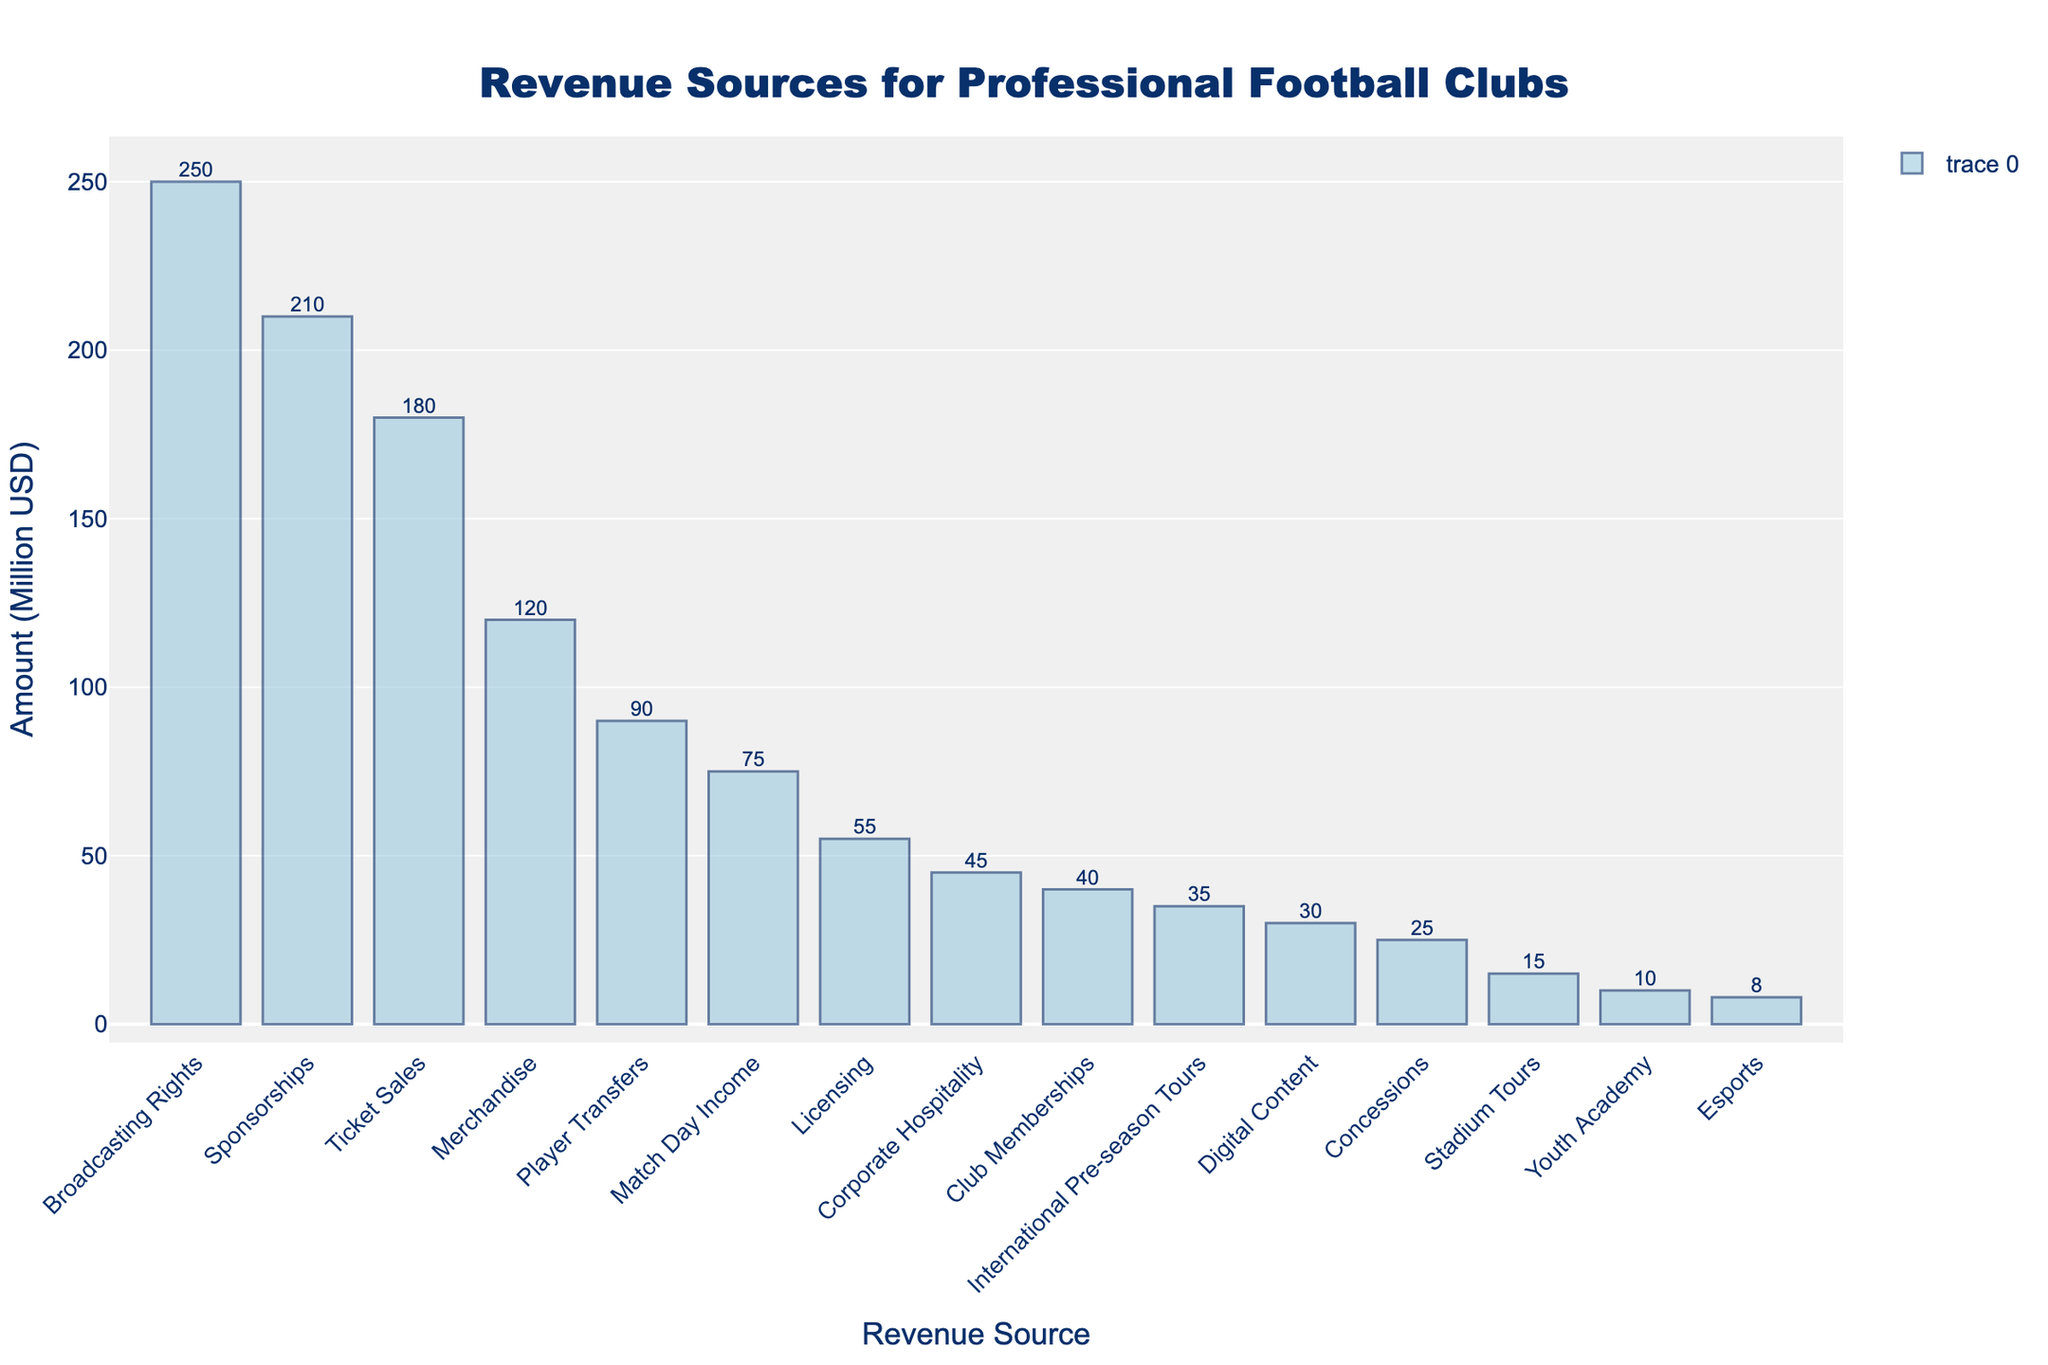which revenue source generated the highest amount? To determine the highest amount generated by a revenue source, look for the tallest bar in the chart. Broadcasting Rights is depicted with the tallest bar.
Answer: Broadcasting Rights how much more revenue do ticket sales generate compared to merchandise? To find the difference in revenue between Ticket Sales and Merchandise, subtract the amount for Merchandise from Ticket Sales. Ticket Sales is 180 million USD and Merchandise is 120 million USD. So, 180 - 120 = 60 million USD.
Answer: 60 million USD what is the combined revenue from player transfers and digital content? To find the combined revenue of Player Transfers and Digital Content, add their amounts. Player Transfers is 90 million USD and Digital Content is 30 million USD. So, 90 + 30 = 120 million USD.
Answer: 120 million USD how many revenue sources generate more than 100 million USD? To answer this, count the bars that have a height corresponding to amounts greater than 100 million USD. They are Broadcasting Rights, Sponsorships, and Ticket Sales. That's 3 revenue sources.
Answer: 3 is club memberships revenue higher than concessions revenue? To compare Club Memberships and Concessions, look at the heights of their bars. Club Memberships generate 40 million USD, and Concessions generate 25 million USD. So, Club Memberships generate more.
Answer: Yes what is the median revenue amount among all revenue sources? To compute the median, first list all the revenue amounts in ascending order: 8, 10, 15, 25, 30, 35, 40, 45, 55, 75, 90, 120, 180, 210, 250. The median is the middle value in this ordered list. With 15 data points, the median is the 8th value, which is 45 million USD.
Answer: 45 million USD how much less is youth academy revenue compared to stadium tours? To determine the difference in revenue between Youth Academy and Stadium Tours, subtract Youth Academy's amount from Stadium Tours. Youth Academy is 10 million USD and Stadium Tours is 15 million USD. So, 15 - 10 = 5 million USD.
Answer: 5 million USD what proportion of total revenue is generated by match day income? First, sum all revenue amounts to find the total revenue. The total is 180 + 120 + 210 + 250 + 90 + 75 + 40 + 15 + 30 + 55 + 25 + 10 + 35 + 8 + 45 = 1188 million USD. Match Day Income is 75 million USD. The proportion is 75 / 1188 ≈ 0.0631. Multiply by 100 to convert to percentage, which is about 6.31%.
Answer: 6.31% what is the difference between the highest and lowest revenue amounts? Find the highest and lowest values from the data set. Broadcasting Rights is the highest at 250 million USD, and Esports is the lowest at 8 million USD. Subtract the lowest from the highest: 250 - 8 = 242 million USD.
Answer: 242 million USD 